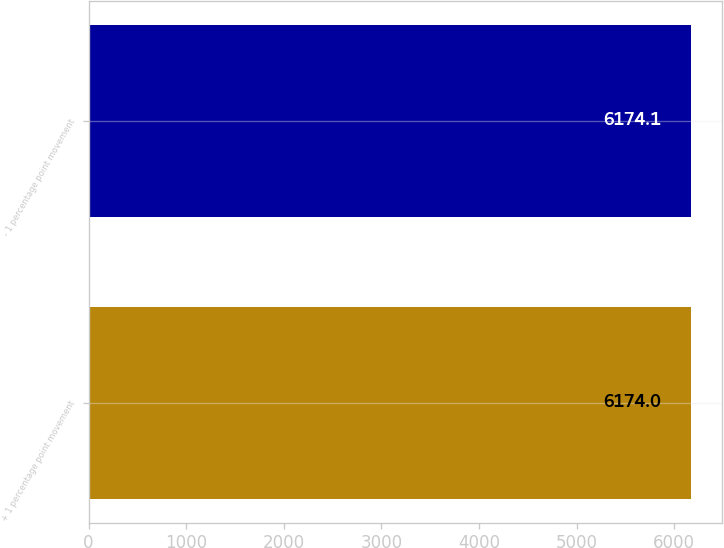Convert chart to OTSL. <chart><loc_0><loc_0><loc_500><loc_500><bar_chart><fcel>+ 1 percentage point movement<fcel>- 1 percentage point movement<nl><fcel>6174<fcel>6174.1<nl></chart> 